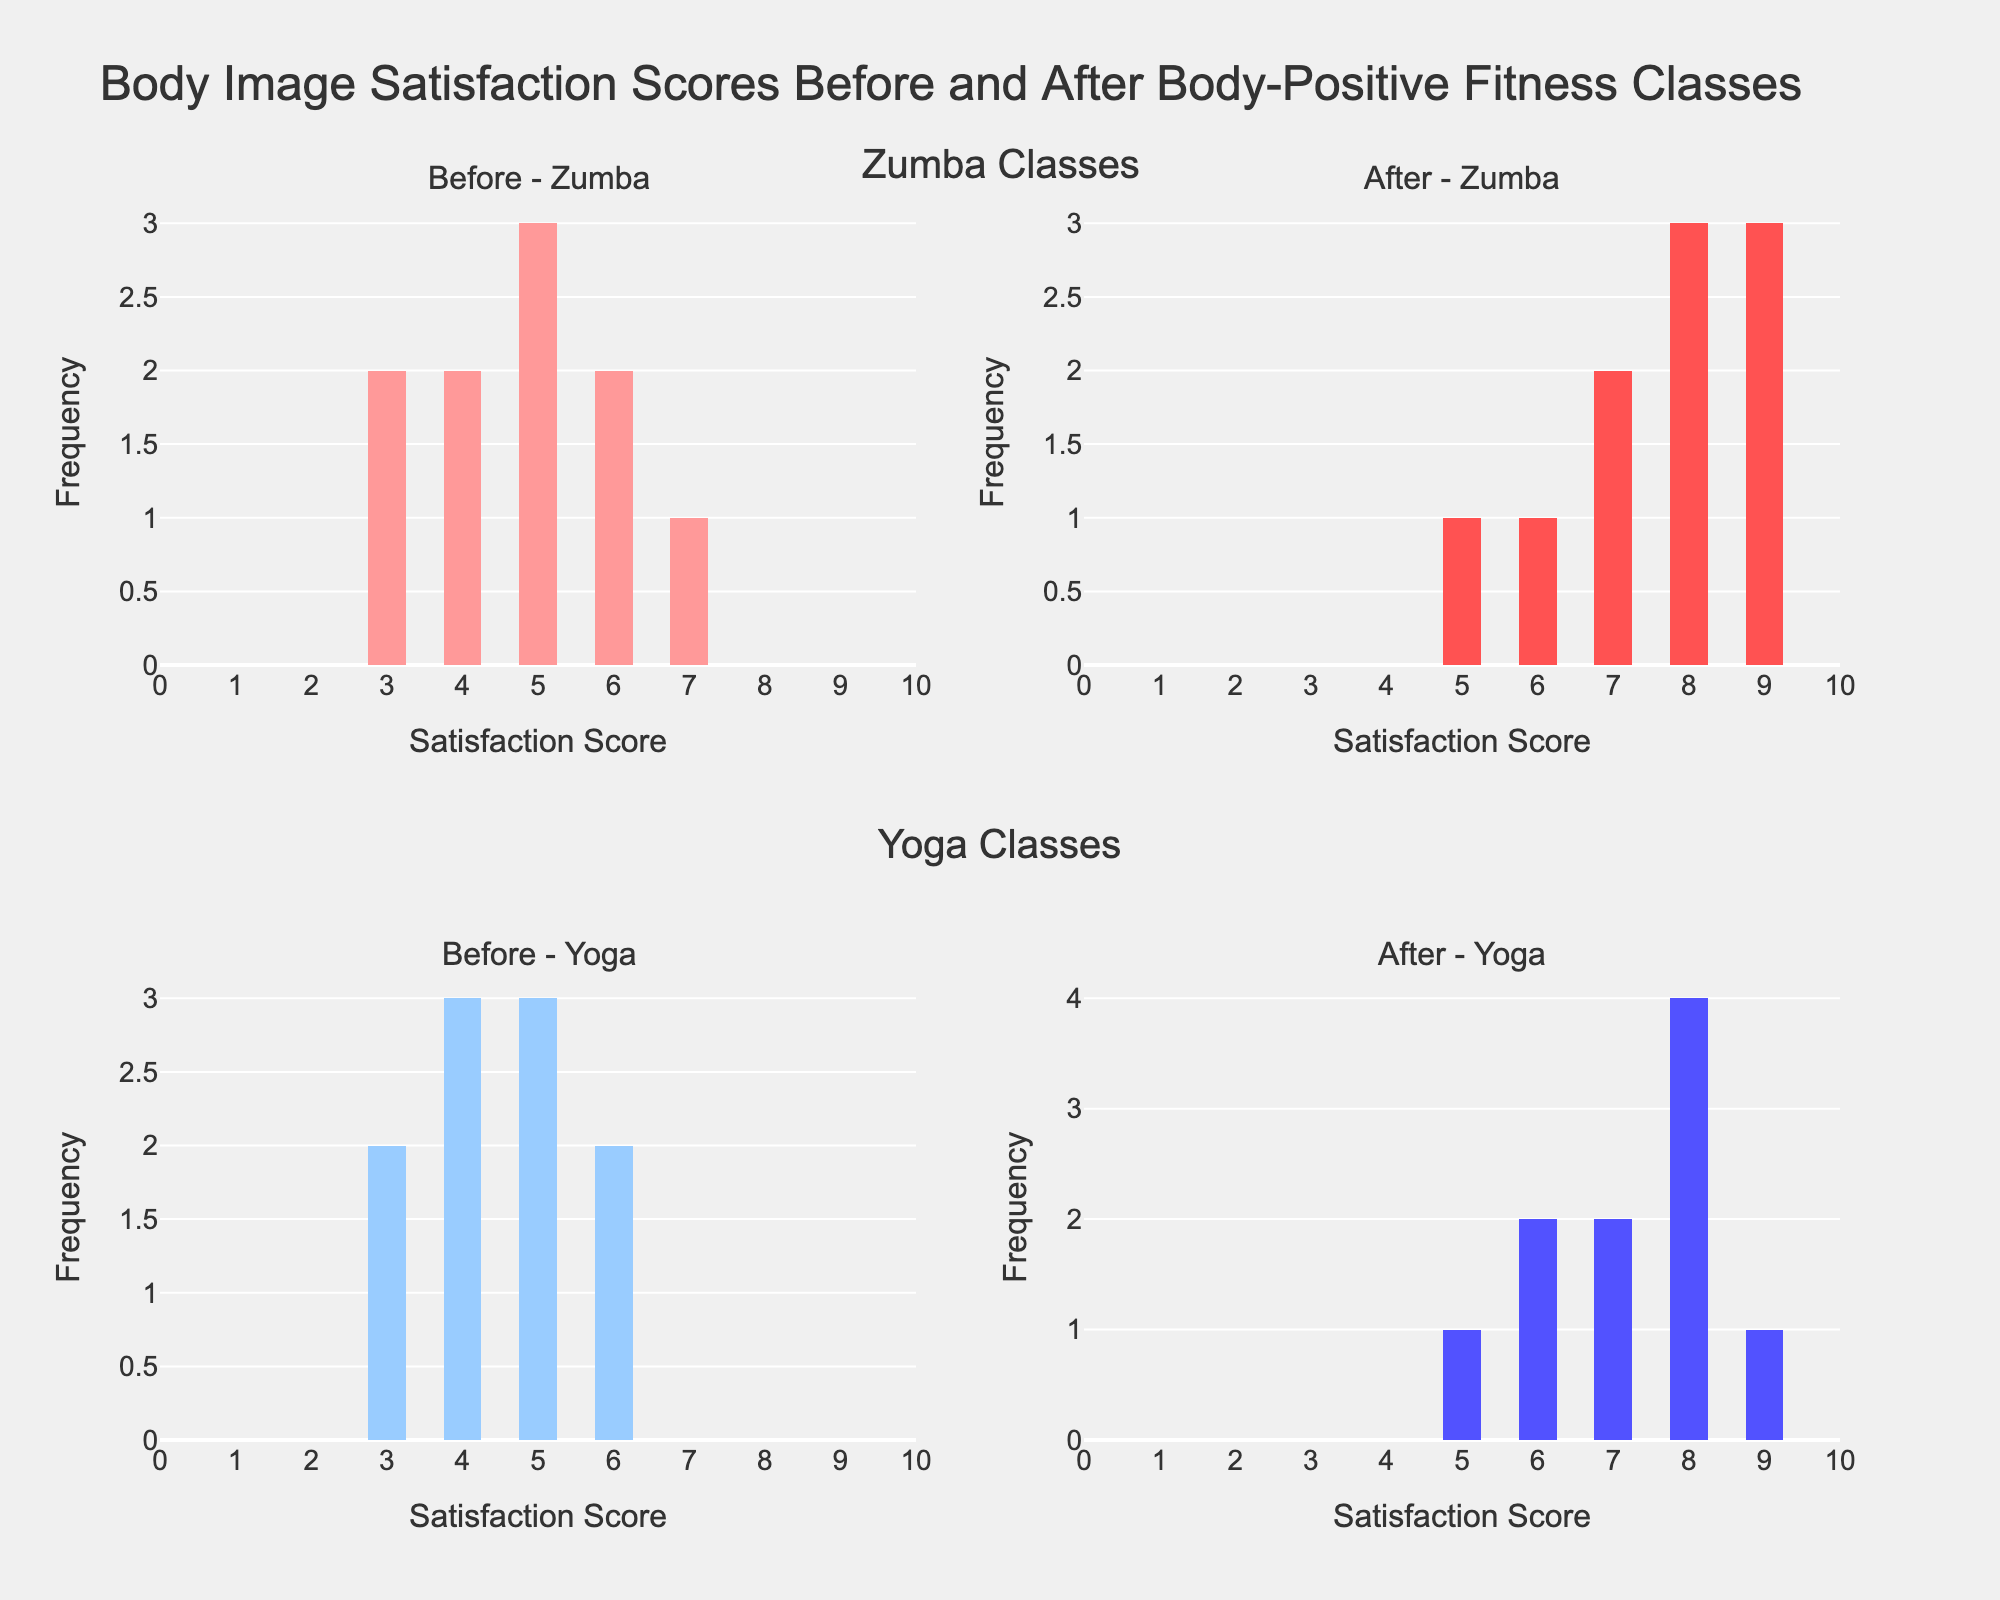What's the title of the figure? The title is usually displayed at the top of the plot and summarizes the information being presented. It reads "Body Image Satisfaction Scores Before and After Body-Positive Fitness Classes".
Answer: Body Image Satisfaction Scores Before and After Body-Positive Fitness Classes How many subplots are there? By visually inspecting the figure layout, we can see that there are four distinct subplots organized in a 2x2 grid.
Answer: 4 What's the color of the histogram bars for "Before - Zumba"? The color can be determined by looking at the histogram bars in the "Before - Zumba" subplot, which are filled with a light red shade.
Answer: Light red What's the range of satisfaction scores shown on the x-axes? The x-axis for all subplots has a shared range which extends from 0 to 10, as indicated by the range being set on the x-axes.
Answer: 0 to 10 What score appears most frequently in the "After - Yoga" subplot? To find the mode, examine the histogram for the "After - Yoga" subplot and identify the bar with the highest frequency count, which is for the score of 8.
Answer: 8 Which class shows a more significant improvement in satisfaction scores? By comparing the histograms, we observe that both "Zumba" and "Yoga" show increases, but "Yoga" seems to have a more pronounced shift in high-frequency scores from 3-6 before to 7-9 after, indicating a more significant improvement.
Answer: Yoga What is the median score in the "Before - Yoga" subplot? To find the median, we need to arrange the scores in numerical order and locate the middle value. The scores are 3, 3, 4, 4, 5, 5, 5, and 6. The median (middle) score for the Yoga class before body-positive fitness classes is 5.
Answer: 5 In which subplot do we see the highest single frequency? By reviewing the highest bars in all subplots, we notice that "After - Yoga" shows the highest frequency for a single satisfaction score, which is 8.
Answer: After - Yoga Which fitness class had the lowest initial satisfaction score? By checking the lowest bars in the "Before - Zumba" and "Before - Yoga" plots, we can see that both have scores starting at 3. Therefore, both classes had the same lowest initial satisfaction scores.
Answer: Zumba and Yoga 